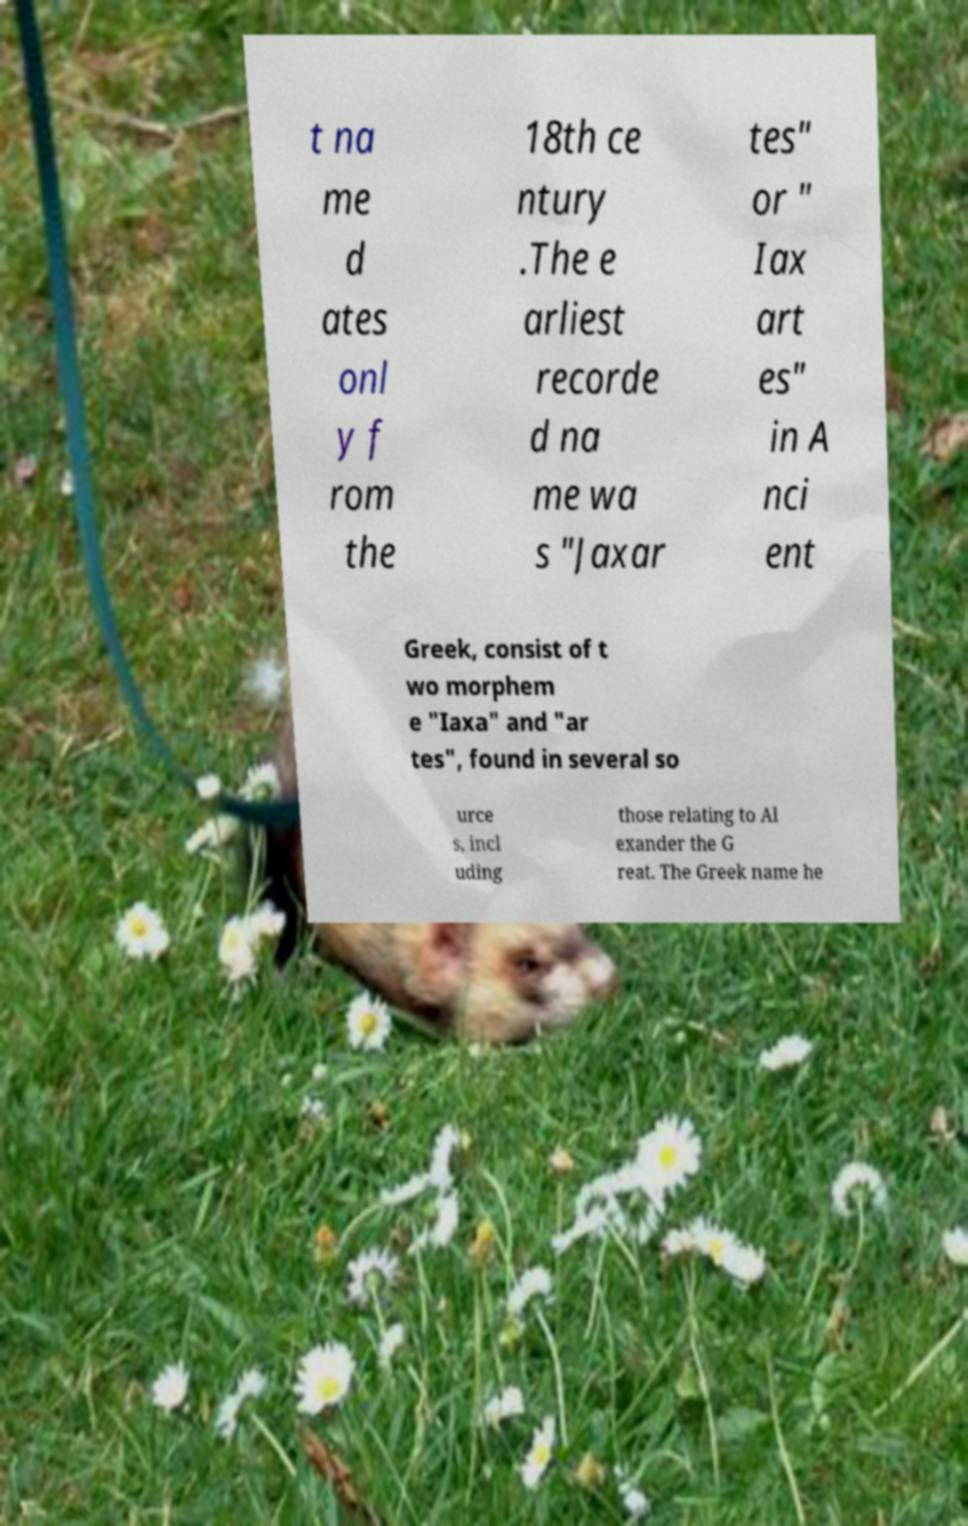Can you read and provide the text displayed in the image?This photo seems to have some interesting text. Can you extract and type it out for me? t na me d ates onl y f rom the 18th ce ntury .The e arliest recorde d na me wa s "Jaxar tes" or " Iax art es" in A nci ent Greek, consist of t wo morphem e "Iaxa" and "ar tes", found in several so urce s, incl uding those relating to Al exander the G reat. The Greek name he 